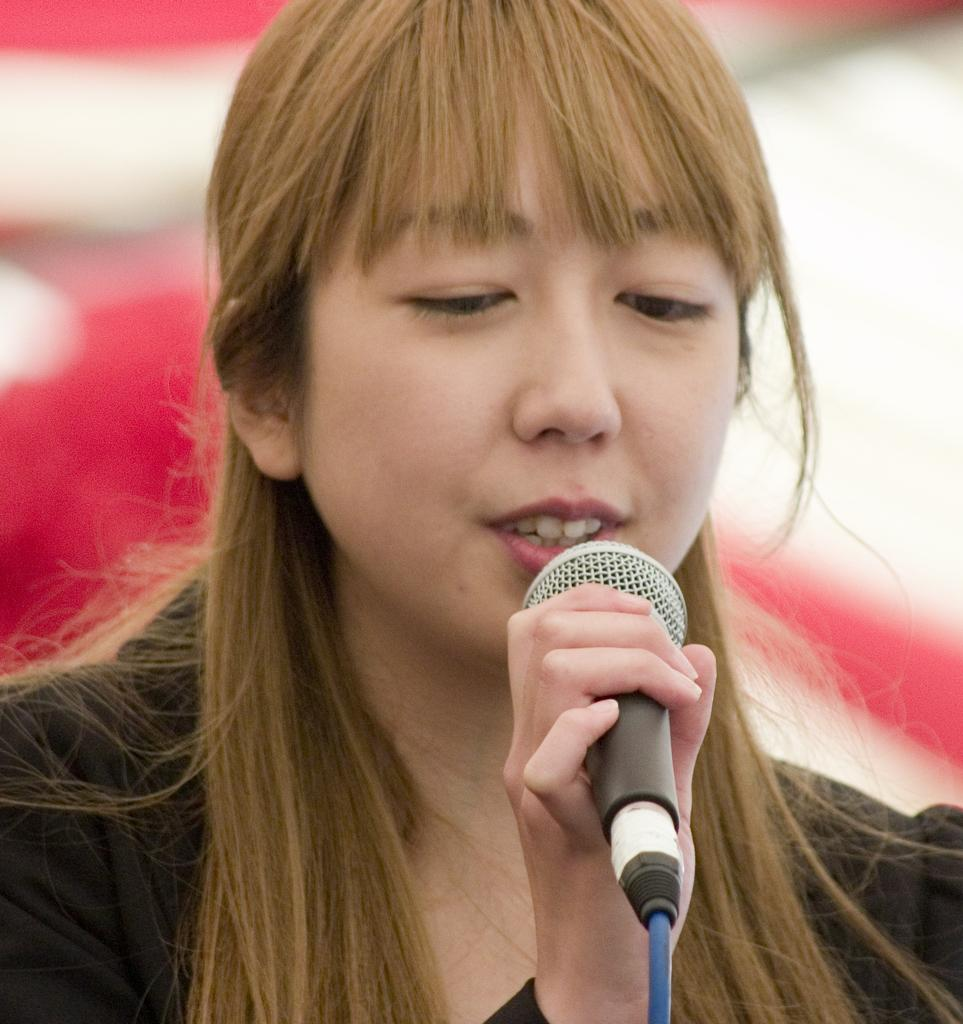Who is the main subject in the image? There is a woman in the image. What is the woman holding in the image? The woman is holding a mic. How many planes can be seen in the image? There are no planes present in the image. Is the woman riding a bike in the image? There is no bike present in the image. 